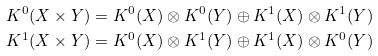Convert formula to latex. <formula><loc_0><loc_0><loc_500><loc_500>K ^ { 0 } ( X \times Y ) & = K ^ { 0 } ( X ) \otimes K ^ { 0 } ( Y ) \oplus K ^ { 1 } ( X ) \otimes K ^ { 1 } ( Y ) \\ K ^ { 1 } ( X \times Y ) & = K ^ { 0 } ( X ) \otimes K ^ { 1 } ( Y ) \oplus K ^ { 1 } ( X ) \otimes K ^ { 0 } ( Y )</formula> 